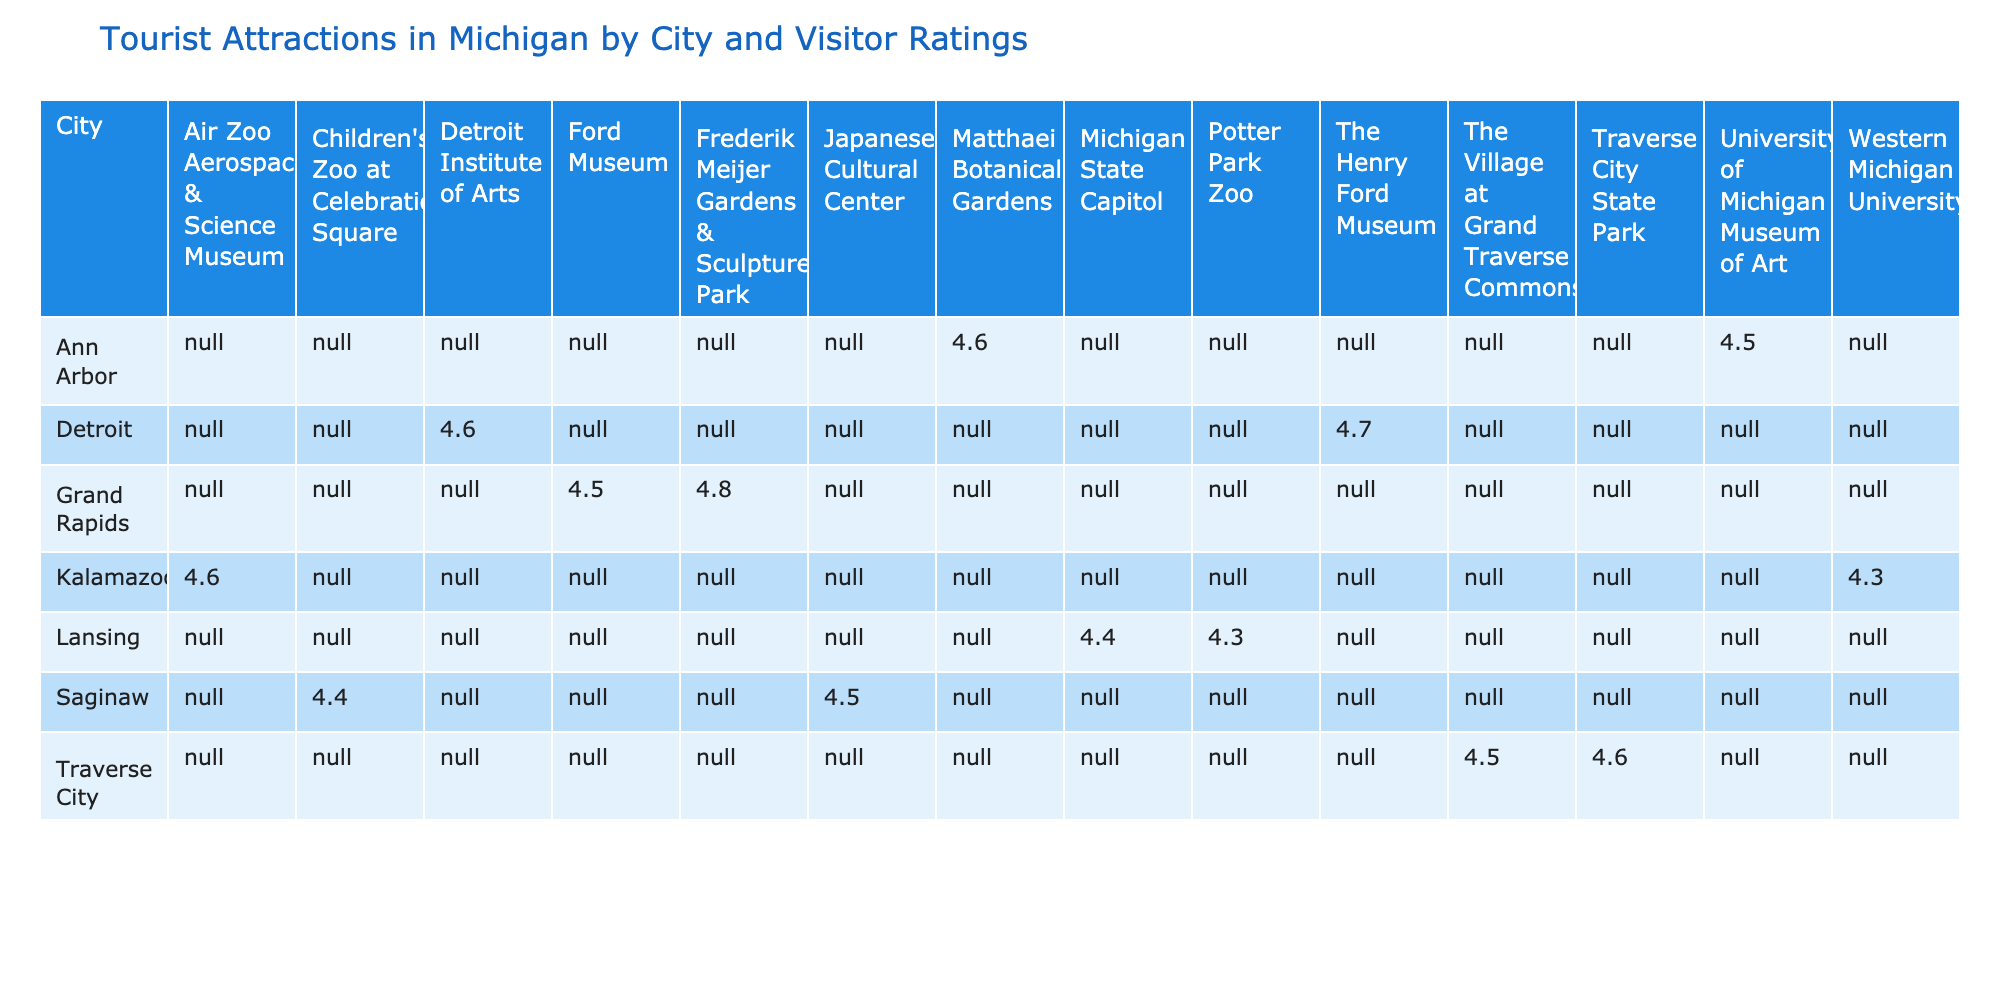What is the visitor rating for the Detroit Institute of Arts? The table lists the attractions in Detroit along with their visitor ratings. According to the table, the visitor rating for the Detroit Institute of Arts is specifically mentioned as 4.6.
Answer: 4.6 Which city has the highest visitor rating attraction, and what is its name? By examining the table, Frederik Meijer Gardens & Sculpture Park in Grand Rapids has the highest visitor rating of 4.8. This can be determined directly from the ratings for attractions in each city, comparing all the values.
Answer: Grand Rapids, Frederik Meijer Gardens & Sculpture Park Is the visitor rating for the University of Michigan Museum of Art higher than 4.5? The visitor rating for the University of Michigan Museum of Art is 4.5 according to the table. Since it is equal and not greater than 4.5, the answer is no.
Answer: No What is the average visitor rating for attractions in Ann Arbor? Ann Arbor has two attractions: the University of Michigan Museum of Art (4.5) and Matthaei Botanical Gardens (4.6). To find the average, we sum the ratings (4.5 + 4.6 = 9.1) and then divide by the number of attractions (2), which results in an average of 4.55.
Answer: 4.55 How many attractions in Kalamazoo have visitor ratings above 4.4? In Kalamazoo, the attractions listed are Air Zoo Aerospace & Science Museum (4.6) and Western Michigan University (4.3). Comparing these ratings, only Air Zoo has a rating above 4.4. Therefore, there is one attraction with a rating above 4.4.
Answer: 1 Which city has the lowest overall visitor rating for its attractions listed in the table? Observing the ratings, Lansing has two attractions with ratings of 4.4 and 4.3, giving an average rating of (4.4 + 4.3) / 2 = 4.35. This is lower than the averages of the other cities, making Lansing the city with the lowest overall rating.
Answer: Lansing Is there an attraction in Saginaw with a visitor rating of 4.5? The table indicates that the Japanese Cultural Center in Saginaw has a visitor rating of 4.5, confirming that there is indeed an attraction with that rating in the city.
Answer: Yes What is the difference in visitor ratings between the highest and the lowest rated attractions in Grand Rapids? In Grand Rapids, the highest rated attraction is Frederik Meijer Gardens & Sculpture Park at 4.8, while the Ford Museum is rated at 4.5. The difference between these ratings is 4.8 - 4.5 = 0.3.
Answer: 0.3 How many total attractions listed have visitor ratings of 4.6 or higher? By reviewing the table, we find that there are a total of 7 attractions with a visitor rating of 4.6 or higher: The Henry Ford Museum (4.7), Detroit Institute of Arts (4.6), Matthaei Botanical Gardens (4.6), Frederik Meijer Gardens & Sculpture Park (4.8), Traverse City State Park (4.6), Air Zoo Aerospace & Science Museum (4.6), and Japanese Cultural Center (4.5). Thus, there are 7 attractions in this category.
Answer: 7 